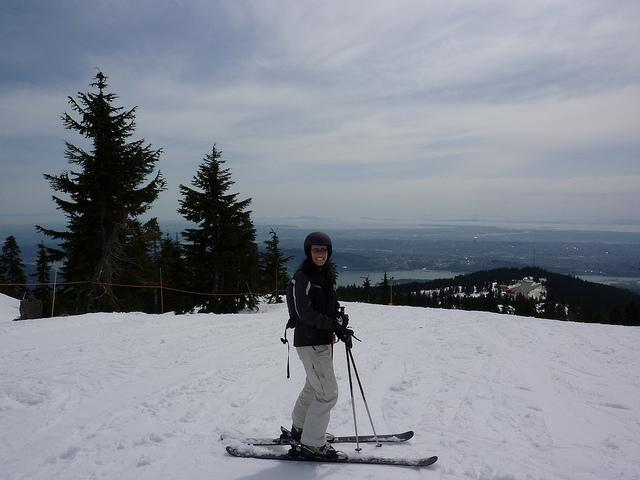How many bicycles are in this photograph?
Give a very brief answer. 0. 